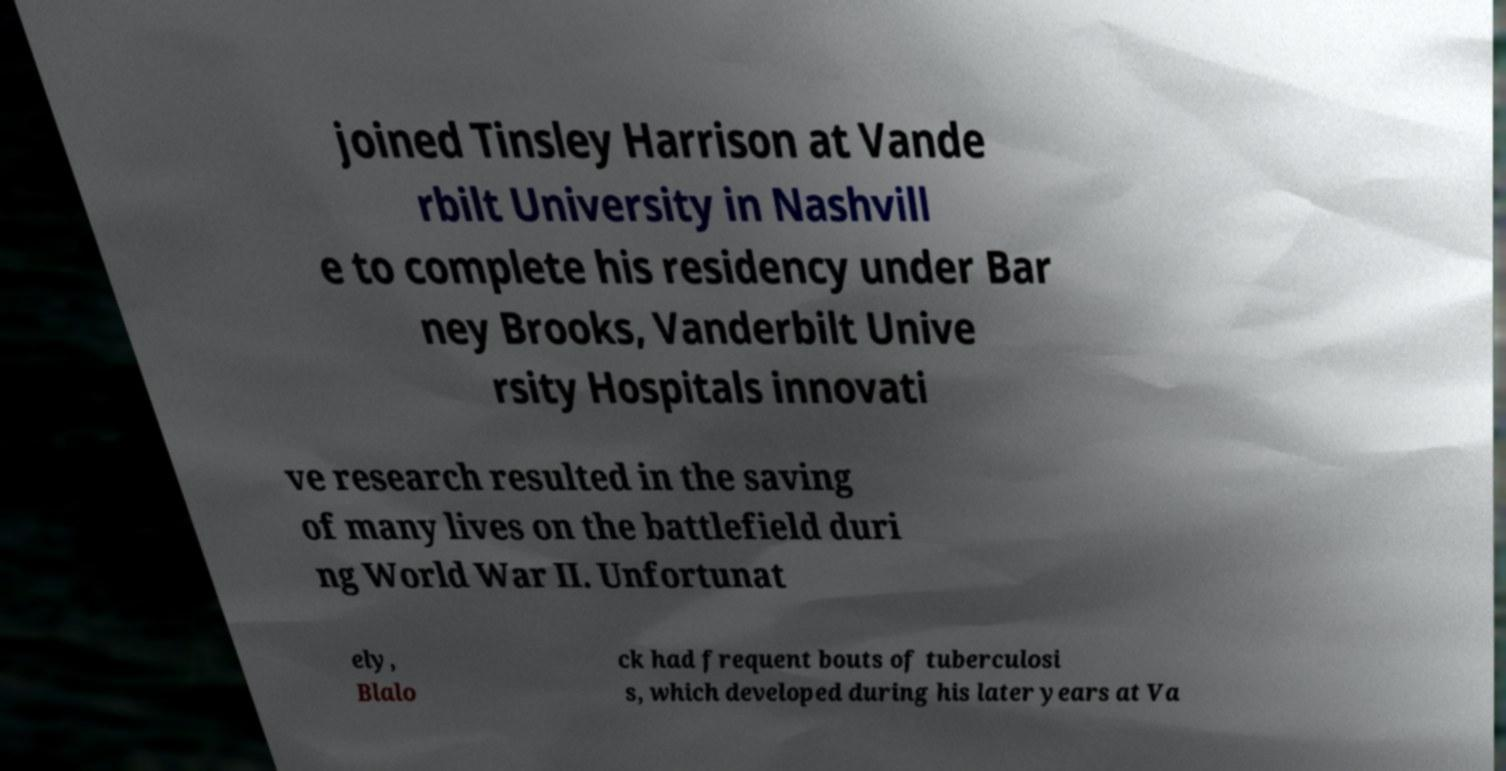Could you extract and type out the text from this image? joined Tinsley Harrison at Vande rbilt University in Nashvill e to complete his residency under Bar ney Brooks, Vanderbilt Unive rsity Hospitals innovati ve research resulted in the saving of many lives on the battlefield duri ng World War II. Unfortunat ely, Blalo ck had frequent bouts of tuberculosi s, which developed during his later years at Va 